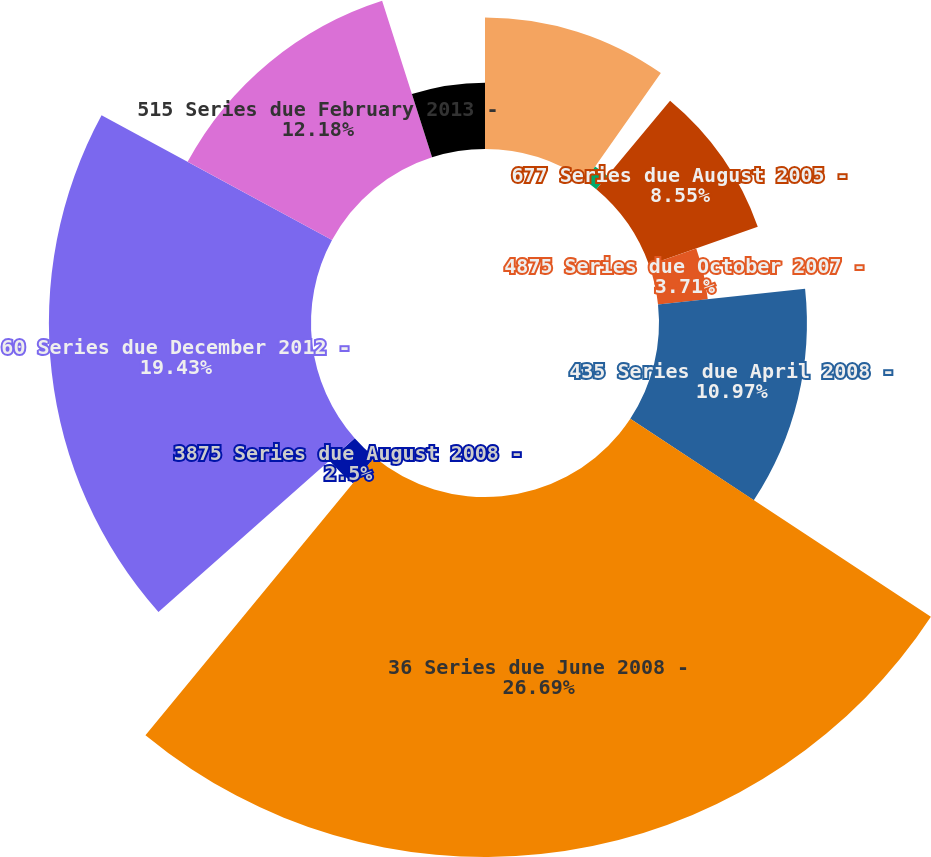Convert chart. <chart><loc_0><loc_0><loc_500><loc_500><pie_chart><fcel>6125 Series due July 2005 -<fcel>8125 Series due July 2005 -<fcel>677 Series due August 2005 -<fcel>4875 Series due October 2007 -<fcel>435 Series due April 2008 -<fcel>36 Series due June 2008 -<fcel>3875 Series due August 2008 -<fcel>60 Series due December 2012 -<fcel>515 Series due February 2013 -<fcel>525 Series due August 2013 -<nl><fcel>9.76%<fcel>1.29%<fcel>8.55%<fcel>3.71%<fcel>10.97%<fcel>26.7%<fcel>2.5%<fcel>19.44%<fcel>12.18%<fcel>4.92%<nl></chart> 